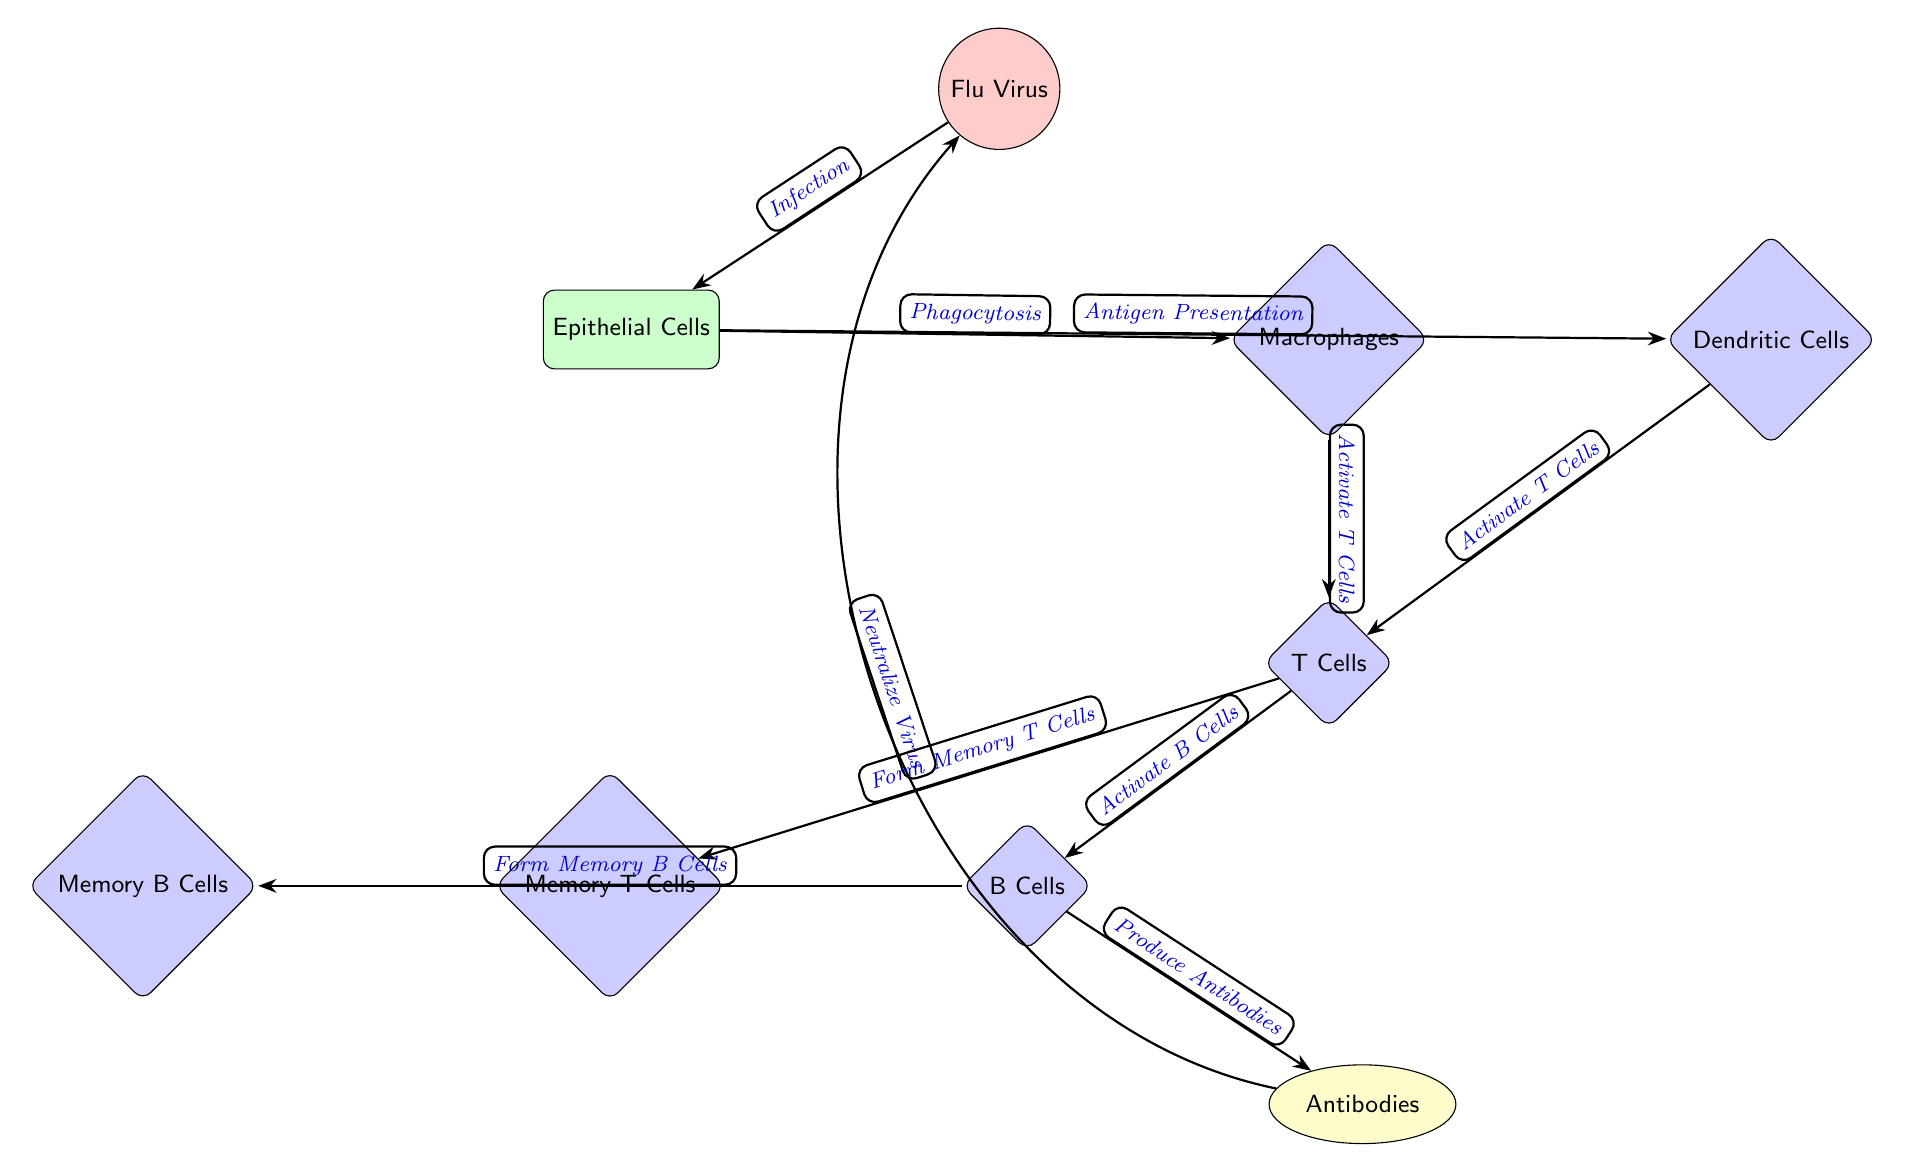What is the main infectious agent represented in the diagram? The primary infectious agent in the diagram is labeled as the "Flu Virus," which resides at the top of the diagram and is depicted as a red circle.
Answer: Flu Virus How many different immune cell types are shown in the diagram? The diagram includes four distinct immune cell types: Macrophages, Dendritic Cells, T Cells, and B Cells, totaling four immune cell types.
Answer: 4 What process do epithelial cells initiate after infection by the flu virus? Following infection by the flu virus, the epithelial cells trigger "Phagocytosis," which is represented by an edge connecting the epithelial cells to macrophages.
Answer: Phagocytosis Which two cell types are responsible for activating T Cells? Both Macrophages and Dendritic Cells are indicated in the diagram as having edges leading to T Cells, signifying their role in T Cell activation.
Answer: Macrophages and Dendritic Cells What do B Cells produce in response to T Cell activation? B Cells are shown to produce "Antibodies," as indicated by the edge connecting B Cells to Antibodies after their activation by T Cells.
Answer: Antibodies Which cell types are indicated to form memory cells? Memory T Cells and Memory B Cells are specifically mentioned in the diagram as formed by T Cells and B Cells, respectively, indicating a mechanism for immunological memory.
Answer: Memory T Cells and Memory B Cells What is the purpose of the antibodies produced by B Cells as illustrated in the diagram? The diagram shows that the antibodies serve to "Neutralize Virus," which is represented by the edge bending back from Antibodies to the Flu Virus, indicating their function in combating the infection.
Answer: Neutralize Virus What interaction occurs between Epithelial Cells and Dendritic Cells? Epithelial Cells present antigens to Dendritic Cells through the process labeled "Antigen Presentation," establishing an interactive role in the immune response.
Answer: Antigen Presentation Which immune cells have a direct pathway for activating B Cells? The diagram indicates that T Cells provide the direct activation pathway for B Cells, as seen by the edge connecting T Cells to B Cells labeled "Activate B Cells."
Answer: T Cells 